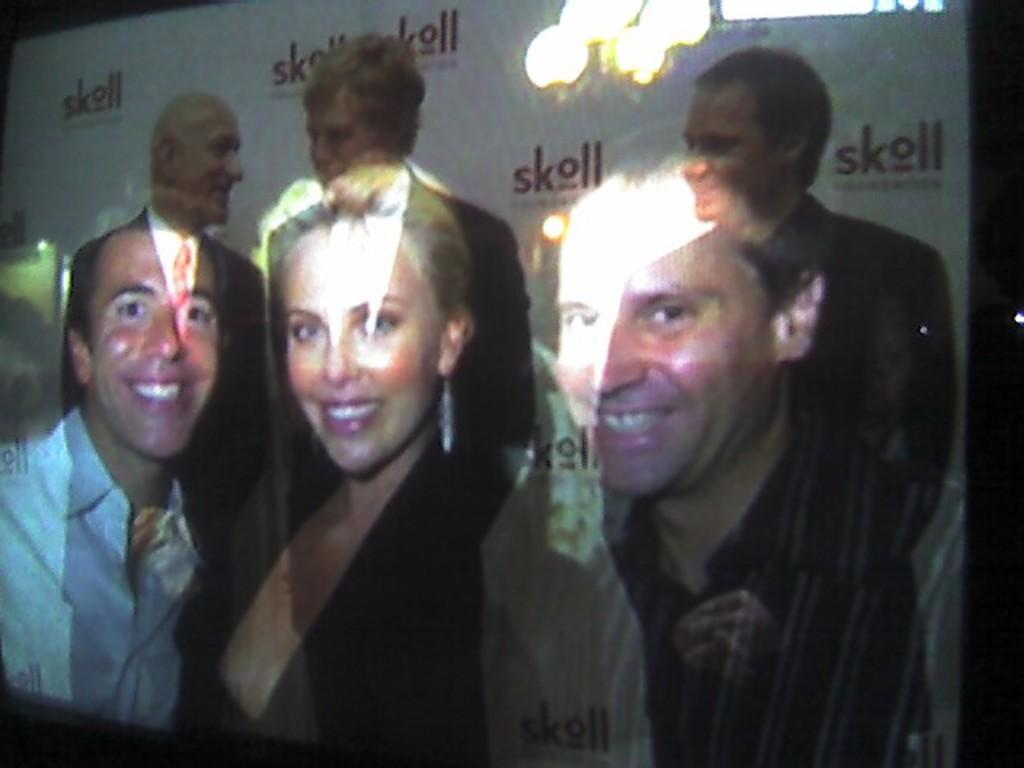How many people are visible on the screen? There are three persons on the screen. Can you describe the reflections in the image? Yes, there is a reflection of two men and one woman. What type of crime is being discussed by the persons on the screen? There is no indication of a discussion or crime in the image; it only shows three persons and their reflections. 